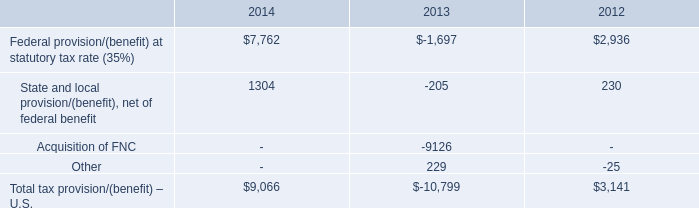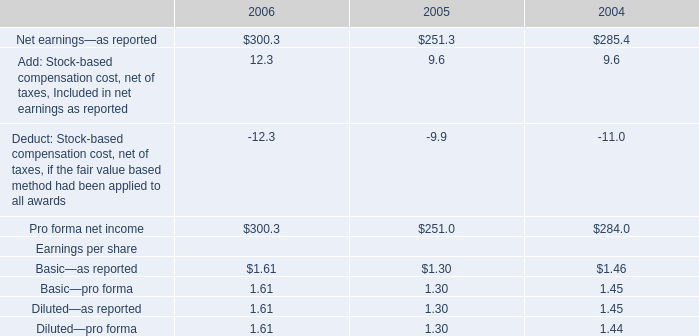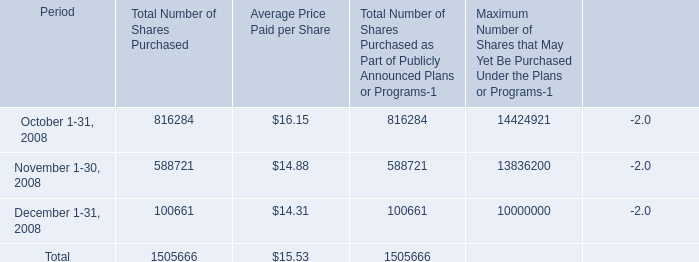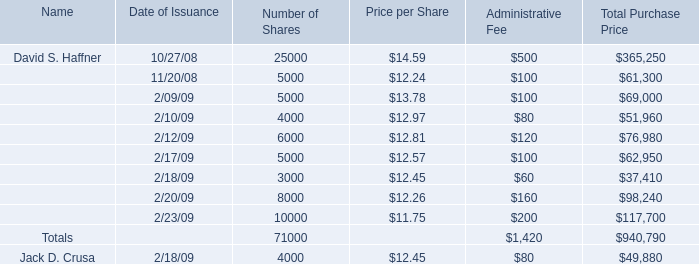What is the ratio of all Price per Share that are in the range of 13 and 15 to the sum of Price per Share for Price per Share? 
Computations: ((14.59 + 13.78) / (((((((((14.59 + 13.78) + 12.24) + 12.97) + 12.81) + 12.57) + 12.45) + 12.26) + 11.75) + 12.45))
Answer: 0.22187. 